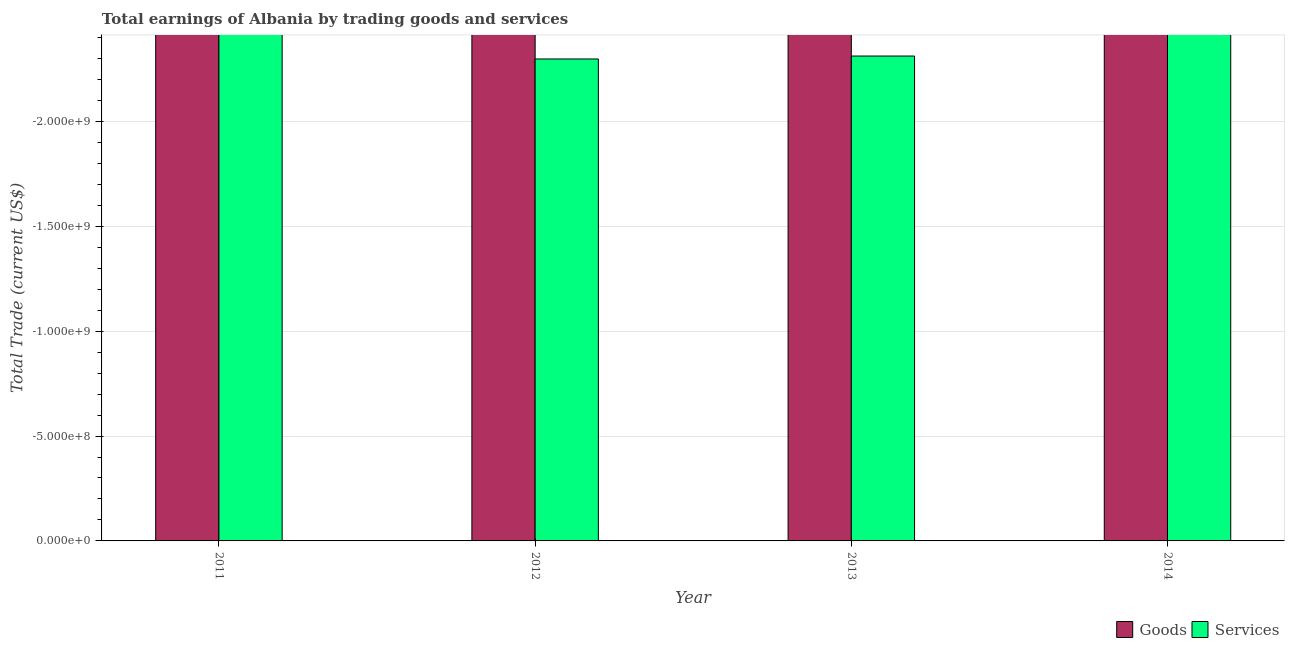Are the number of bars per tick equal to the number of legend labels?
Give a very brief answer. No. Are the number of bars on each tick of the X-axis equal?
Give a very brief answer. Yes. How many bars are there on the 3rd tick from the right?
Your answer should be compact. 0. Across all years, what is the minimum amount earned by trading goods?
Provide a succinct answer. 0. What is the average amount earned by trading goods per year?
Your answer should be compact. 0. In how many years, is the amount earned by trading goods greater than -100000000 US$?
Offer a terse response. 0. In how many years, is the amount earned by trading services greater than the average amount earned by trading services taken over all years?
Your response must be concise. 0. How many bars are there?
Your answer should be very brief. 0. What is the difference between two consecutive major ticks on the Y-axis?
Provide a short and direct response. 5.00e+08. Are the values on the major ticks of Y-axis written in scientific E-notation?
Your answer should be compact. Yes. Does the graph contain grids?
Provide a succinct answer. Yes. What is the title of the graph?
Offer a very short reply. Total earnings of Albania by trading goods and services. Does "Resident workers" appear as one of the legend labels in the graph?
Your answer should be very brief. No. What is the label or title of the X-axis?
Your response must be concise. Year. What is the label or title of the Y-axis?
Offer a terse response. Total Trade (current US$). What is the Total Trade (current US$) of Goods in 2011?
Ensure brevity in your answer.  0. What is the Total Trade (current US$) of Services in 2012?
Your answer should be compact. 0. What is the Total Trade (current US$) of Services in 2013?
Ensure brevity in your answer.  0. What is the Total Trade (current US$) of Goods in 2014?
Give a very brief answer. 0. 